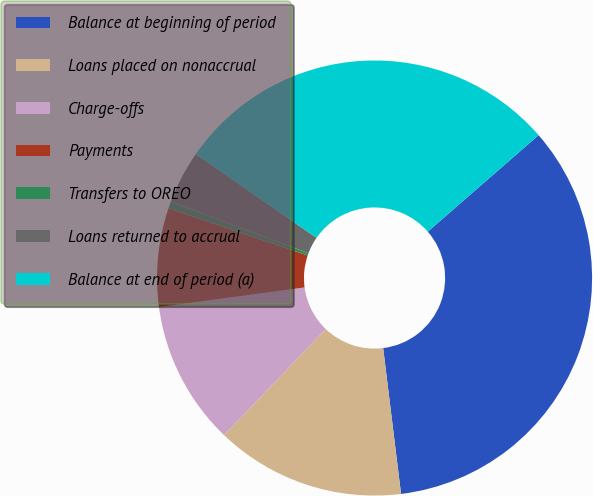Convert chart. <chart><loc_0><loc_0><loc_500><loc_500><pie_chart><fcel>Balance at beginning of period<fcel>Loans placed on nonaccrual<fcel>Charge-offs<fcel>Payments<fcel>Transfers to OREO<fcel>Loans returned to accrual<fcel>Balance at end of period (a)<nl><fcel>34.46%<fcel>14.1%<fcel>10.71%<fcel>7.32%<fcel>0.53%<fcel>3.93%<fcel>28.95%<nl></chart> 